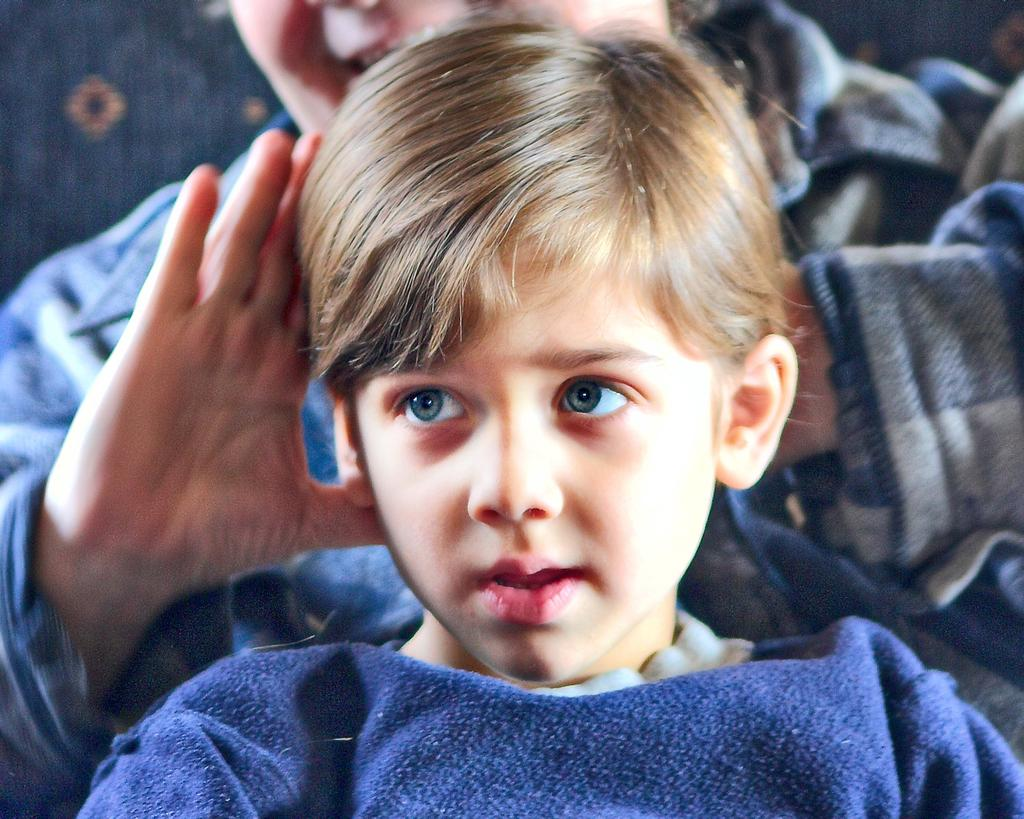Who is present in the image? There is a person and a kid in the image. What is the kid wearing? The kid is wearing a blue t-shirt. What type of pig can be seen sitting on the cushion in the image? There is no pig or cushion present in the image. 